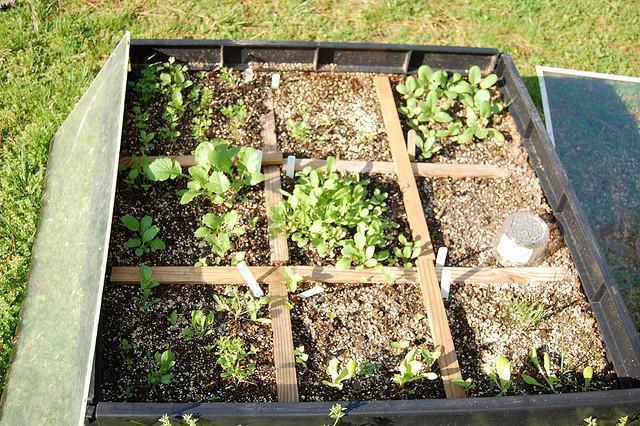How many sections in the garden?
Give a very brief answer. 9. 